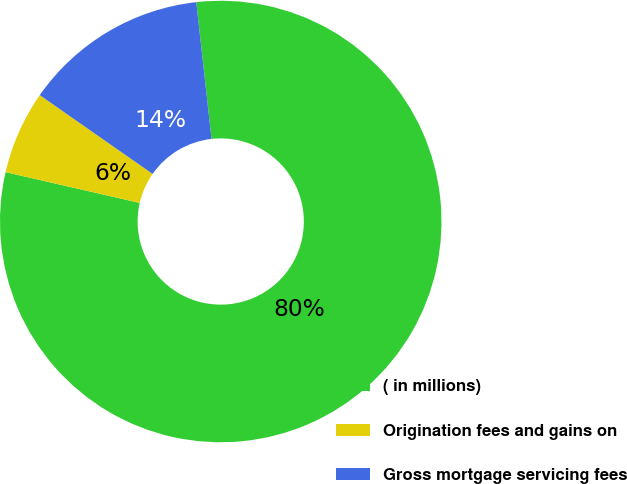<chart> <loc_0><loc_0><loc_500><loc_500><pie_chart><fcel>( in millions)<fcel>Origination fees and gains on<fcel>Gross mortgage servicing fees<nl><fcel>80.36%<fcel>6.11%<fcel>13.53%<nl></chart> 